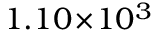<formula> <loc_0><loc_0><loc_500><loc_500>1 . 1 0 \, \times \, 1 0 ^ { 3 }</formula> 